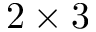Convert formula to latex. <formula><loc_0><loc_0><loc_500><loc_500>2 \times 3</formula> 